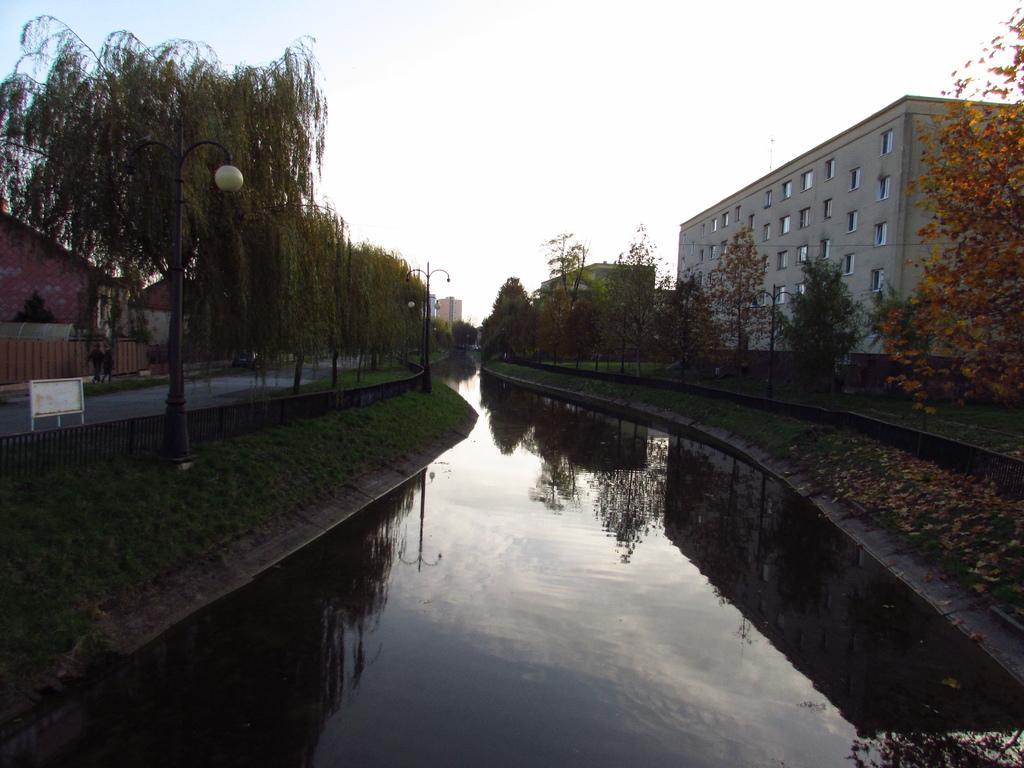How would you summarize this image in a sentence or two? In this image, there are trees, buildings, light poles, grass, iron grilles and a canal. On the left side of the image, I can see a board and two persons on a pathway. In the background there is the sky. 